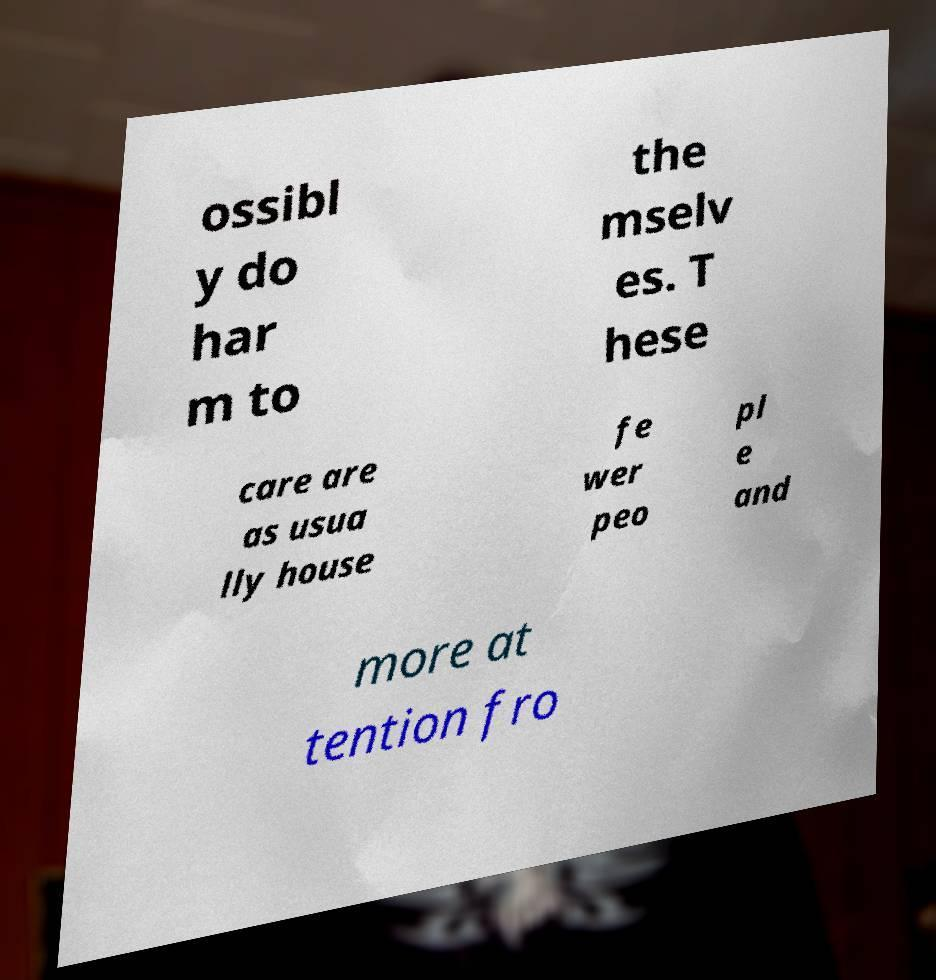Can you accurately transcribe the text from the provided image for me? ossibl y do har m to the mselv es. T hese care are as usua lly house fe wer peo pl e and more at tention fro 